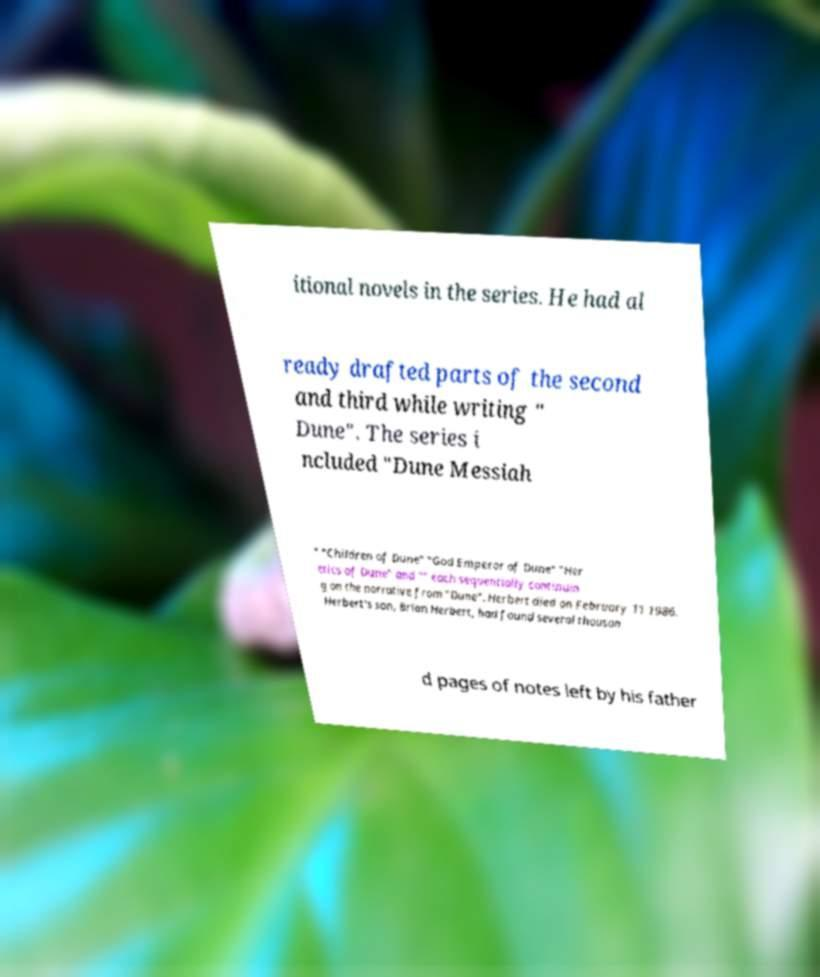Could you extract and type out the text from this image? itional novels in the series. He had al ready drafted parts of the second and third while writing " Dune". The series i ncluded "Dune Messiah " "Children of Dune" "God Emperor of Dune" "Her etics of Dune" and "" each sequentially continuin g on the narrative from "Dune". Herbert died on February 11 1986. Herbert's son, Brian Herbert, had found several thousan d pages of notes left by his father 